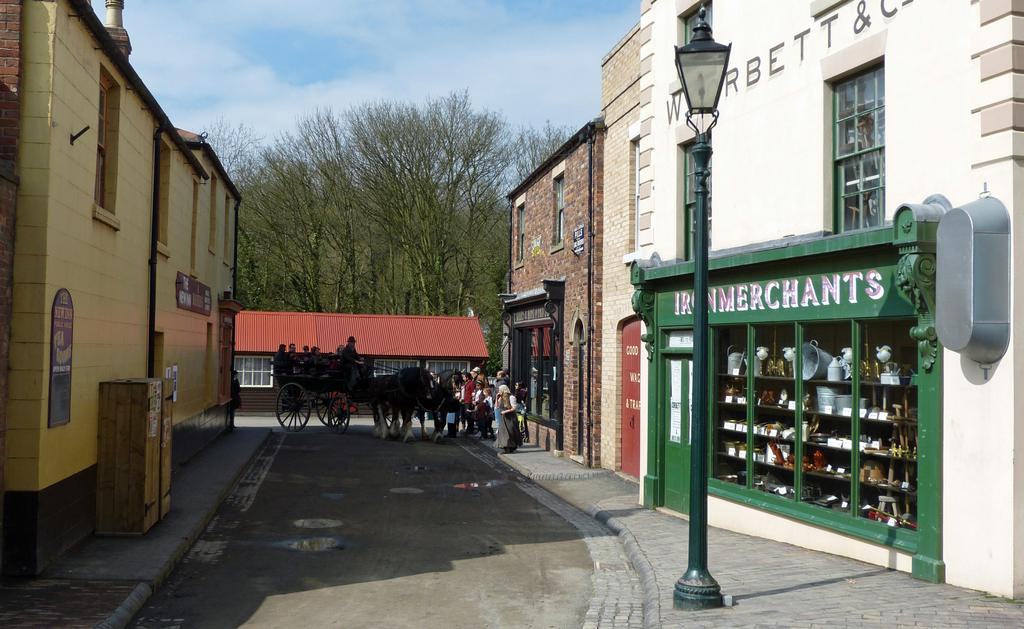Provide a one-sentence caption for the provided image. PEOPLE LOOKING AT A HORSE DRAWN CARRIAGE IN AN ALLEYWAY CLOSE TO IRON MERCHANTS. 